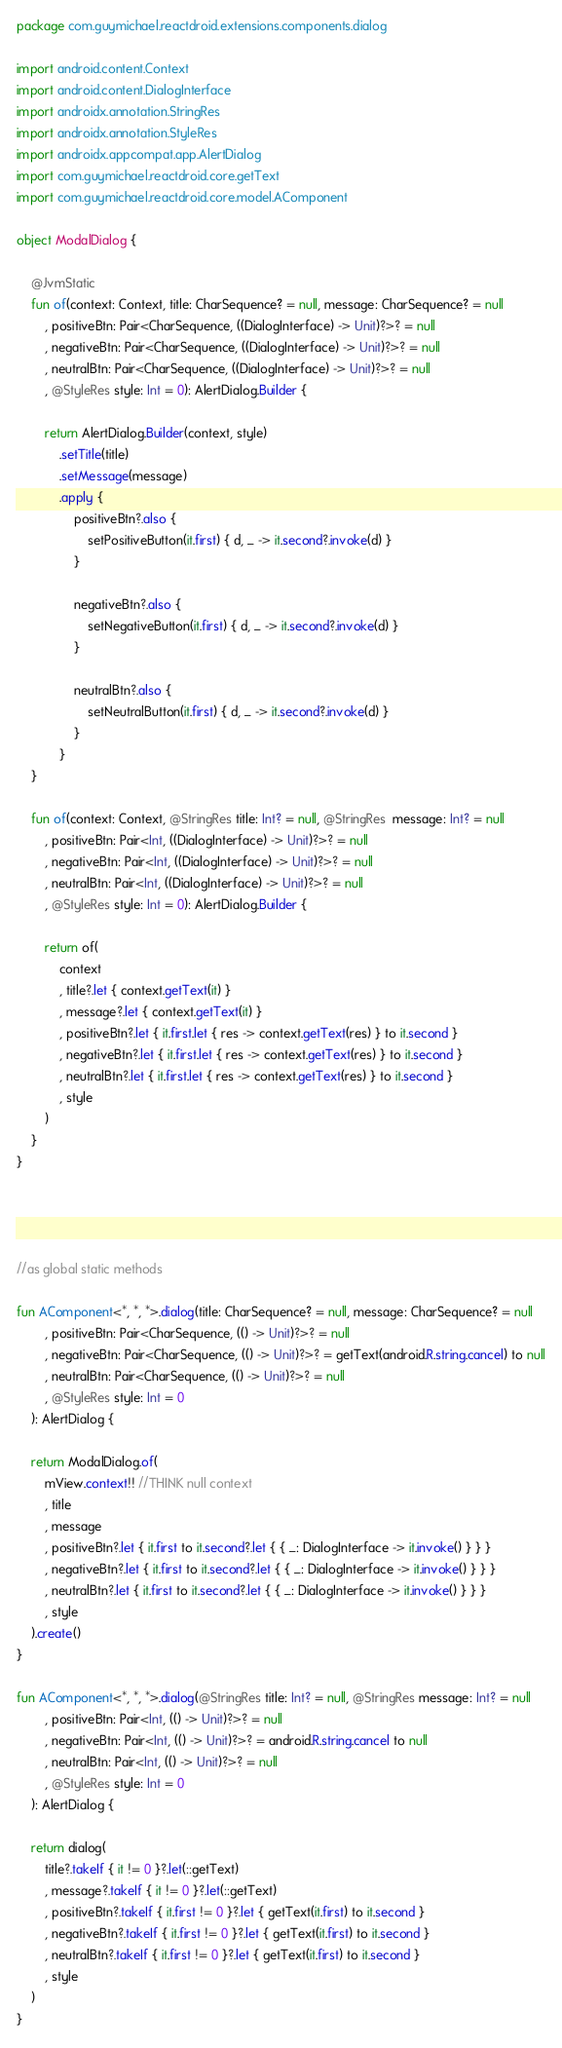<code> <loc_0><loc_0><loc_500><loc_500><_Kotlin_>package com.guymichael.reactdroid.extensions.components.dialog

import android.content.Context
import android.content.DialogInterface
import androidx.annotation.StringRes
import androidx.annotation.StyleRes
import androidx.appcompat.app.AlertDialog
import com.guymichael.reactdroid.core.getText
import com.guymichael.reactdroid.core.model.AComponent

object ModalDialog {

    @JvmStatic
    fun of(context: Context, title: CharSequence? = null, message: CharSequence? = null
        , positiveBtn: Pair<CharSequence, ((DialogInterface) -> Unit)?>? = null
        , negativeBtn: Pair<CharSequence, ((DialogInterface) -> Unit)?>? = null
        , neutralBtn: Pair<CharSequence, ((DialogInterface) -> Unit)?>? = null
        , @StyleRes style: Int = 0): AlertDialog.Builder {

        return AlertDialog.Builder(context, style)
            .setTitle(title)
            .setMessage(message)
            .apply {
                positiveBtn?.also {
                    setPositiveButton(it.first) { d, _ -> it.second?.invoke(d) }
                }

                negativeBtn?.also {
                    setNegativeButton(it.first) { d, _ -> it.second?.invoke(d) }
                }

                neutralBtn?.also {
                    setNeutralButton(it.first) { d, _ -> it.second?.invoke(d) }
                }
            }
    }

    fun of(context: Context, @StringRes title: Int? = null, @StringRes  message: Int? = null
        , positiveBtn: Pair<Int, ((DialogInterface) -> Unit)?>? = null
        , negativeBtn: Pair<Int, ((DialogInterface) -> Unit)?>? = null
        , neutralBtn: Pair<Int, ((DialogInterface) -> Unit)?>? = null
        , @StyleRes style: Int = 0): AlertDialog.Builder {

        return of(
            context
            , title?.let { context.getText(it) }
            , message?.let { context.getText(it) }
            , positiveBtn?.let { it.first.let { res -> context.getText(res) } to it.second }
            , negativeBtn?.let { it.first.let { res -> context.getText(res) } to it.second }
            , neutralBtn?.let { it.first.let { res -> context.getText(res) } to it.second }
            , style
        )
    }
}




//as global static methods

fun AComponent<*, *, *>.dialog(title: CharSequence? = null, message: CharSequence? = null
        , positiveBtn: Pair<CharSequence, (() -> Unit)?>? = null
        , negativeBtn: Pair<CharSequence, (() -> Unit)?>? = getText(android.R.string.cancel) to null
        , neutralBtn: Pair<CharSequence, (() -> Unit)?>? = null
        , @StyleRes style: Int = 0
    ): AlertDialog {

    return ModalDialog.of(
        mView.context!! //THINK null context
        , title
        , message
        , positiveBtn?.let { it.first to it.second?.let { { _: DialogInterface -> it.invoke() } } }
        , negativeBtn?.let { it.first to it.second?.let { { _: DialogInterface -> it.invoke() } } }
        , neutralBtn?.let { it.first to it.second?.let { { _: DialogInterface -> it.invoke() } } }
        , style
    ).create()
}

fun AComponent<*, *, *>.dialog(@StringRes title: Int? = null, @StringRes message: Int? = null
        , positiveBtn: Pair<Int, (() -> Unit)?>? = null
        , negativeBtn: Pair<Int, (() -> Unit)?>? = android.R.string.cancel to null
        , neutralBtn: Pair<Int, (() -> Unit)?>? = null
        , @StyleRes style: Int = 0
    ): AlertDialog {

    return dialog(
        title?.takeIf { it != 0 }?.let(::getText)
        , message?.takeIf { it != 0 }?.let(::getText)
        , positiveBtn?.takeIf { it.first != 0 }?.let { getText(it.first) to it.second }
        , negativeBtn?.takeIf { it.first != 0 }?.let { getText(it.first) to it.second }
        , neutralBtn?.takeIf { it.first != 0 }?.let { getText(it.first) to it.second }
        , style
    )
}</code> 